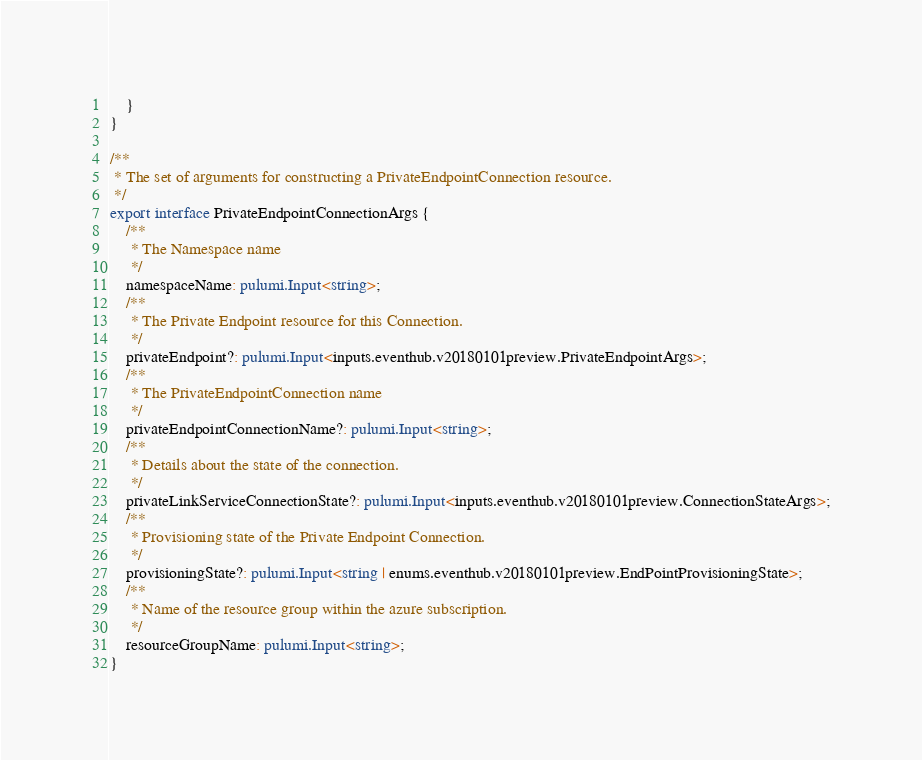Convert code to text. <code><loc_0><loc_0><loc_500><loc_500><_TypeScript_>    }
}

/**
 * The set of arguments for constructing a PrivateEndpointConnection resource.
 */
export interface PrivateEndpointConnectionArgs {
    /**
     * The Namespace name
     */
    namespaceName: pulumi.Input<string>;
    /**
     * The Private Endpoint resource for this Connection.
     */
    privateEndpoint?: pulumi.Input<inputs.eventhub.v20180101preview.PrivateEndpointArgs>;
    /**
     * The PrivateEndpointConnection name
     */
    privateEndpointConnectionName?: pulumi.Input<string>;
    /**
     * Details about the state of the connection.
     */
    privateLinkServiceConnectionState?: pulumi.Input<inputs.eventhub.v20180101preview.ConnectionStateArgs>;
    /**
     * Provisioning state of the Private Endpoint Connection.
     */
    provisioningState?: pulumi.Input<string | enums.eventhub.v20180101preview.EndPointProvisioningState>;
    /**
     * Name of the resource group within the azure subscription.
     */
    resourceGroupName: pulumi.Input<string>;
}
</code> 